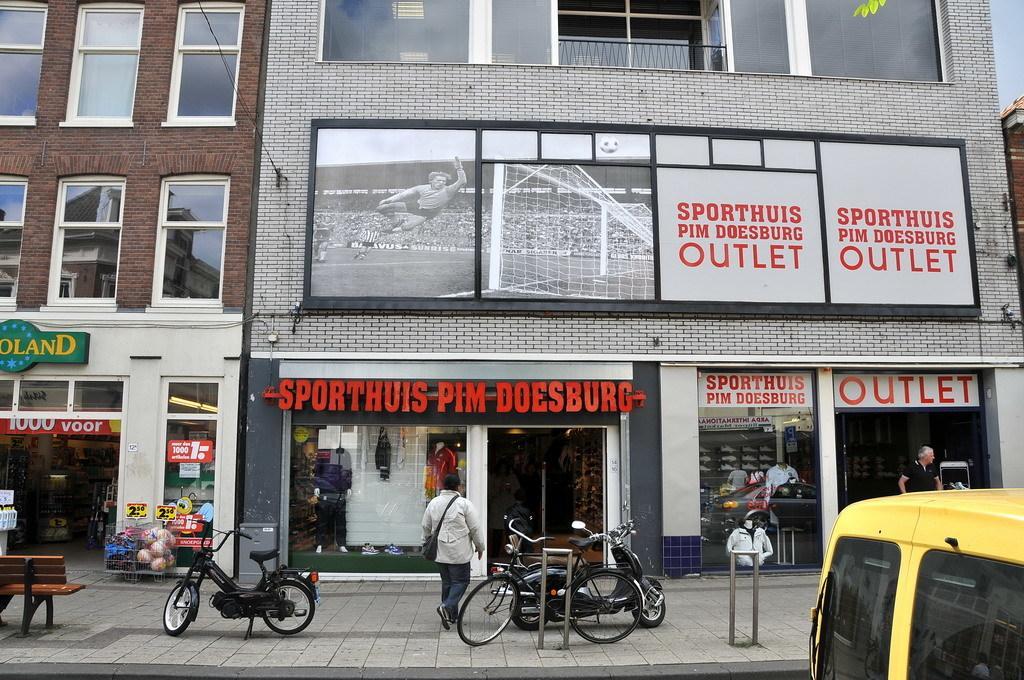Can you describe this image briefly? In this picture there are buildings. There are boards on the wall, there is text on the boards. In the foreground there are motorbikes and there is a bicycle on the footpath and there are objects on the footpath. At the bottom right there is a vehicle. There are two people on the footpath. At the top there is sky. At the bottom there is a road. 